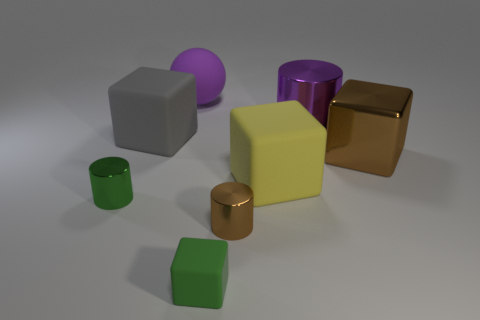There is a yellow matte cube to the right of the thing in front of the shiny cylinder in front of the green cylinder; how big is it?
Your answer should be very brief. Large. There is a rubber thing that is behind the purple shiny object; is it the same color as the small cylinder that is to the right of the green shiny object?
Keep it short and to the point. No. What number of purple objects are matte spheres or rubber cylinders?
Your response must be concise. 1. What number of green metallic cylinders have the same size as the green matte thing?
Make the answer very short. 1. Are the green object that is in front of the brown metal cylinder and the large purple sphere made of the same material?
Ensure brevity in your answer.  Yes. There is a large rubber cube left of the small green cube; is there a big purple ball that is in front of it?
Ensure brevity in your answer.  No. There is a big yellow object that is the same shape as the small matte thing; what material is it?
Offer a very short reply. Rubber. Is the number of brown blocks in front of the tiny green metallic cylinder greater than the number of brown shiny cylinders to the left of the big matte ball?
Offer a very short reply. No. There is a tiny thing that is made of the same material as the purple ball; what is its shape?
Provide a succinct answer. Cube. Are there more large blocks that are to the left of the large purple metallic cylinder than large cylinders?
Make the answer very short. Yes. 